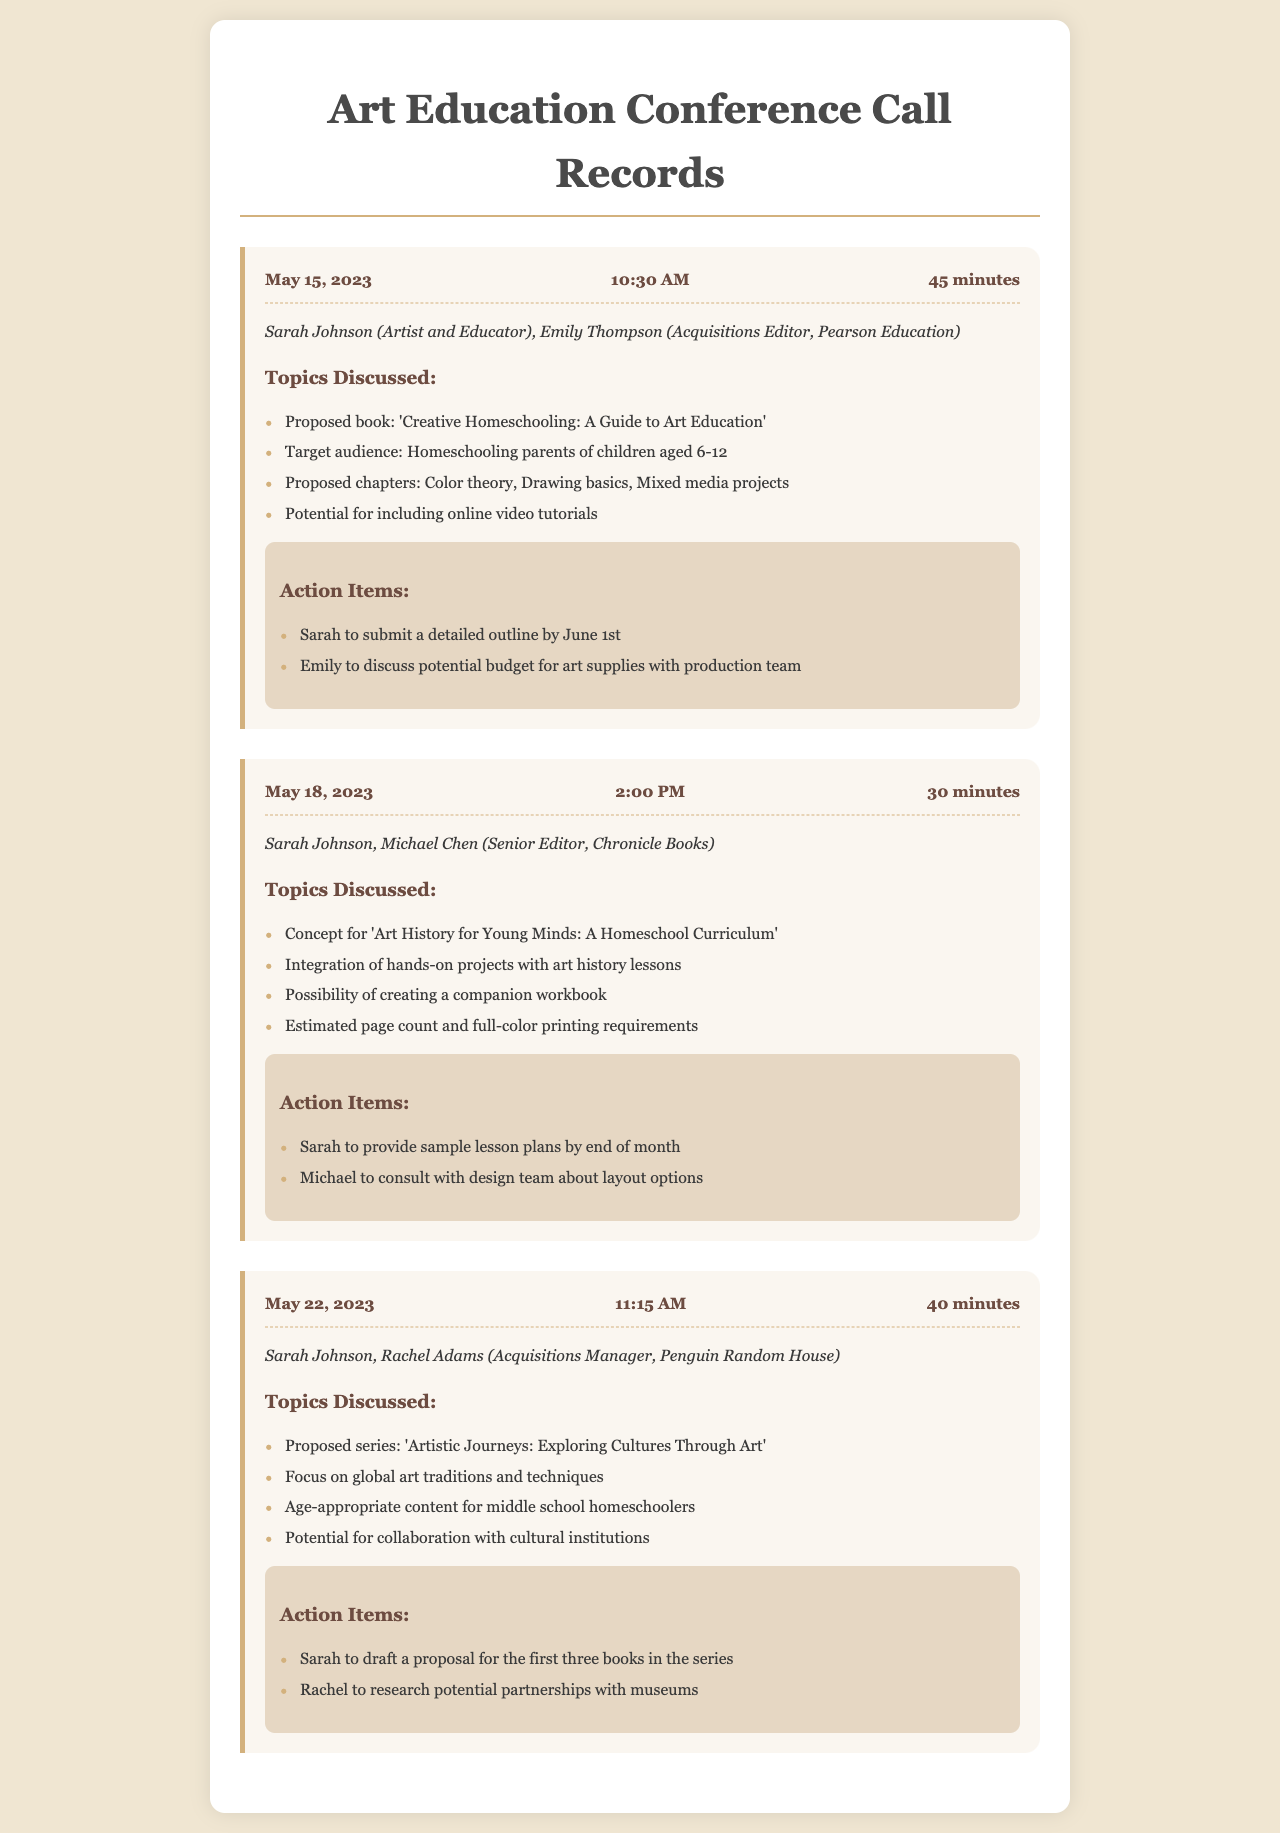What is the date of the first call? The date of the first call is found in the call record header.
Answer: May 15, 2023 Who was the acquisitions editor for Pearson Education? The name of the acquisitions editor for Pearson Education is mentioned in the call record under participants.
Answer: Emily Thompson What is the proposed title of the first book discussed? The proposed book title is listed in the topics discussed section of the first call record.
Answer: Creative Homeschooling: A Guide to Art Education How long was the second conference call? The duration of the second call is specified in the call record header.
Answer: 30 minutes Which participant is responsible for providing sample lesson plans? The action items section lists who is responsible for providing sample lesson plans in the second call record.
Answer: Sarah What series was discussed in the third call? The proposed series title can be found in the topics discussed section of the third call record.
Answer: Artistic Journeys: Exploring Cultures Through Art Which company is Rachel Adams associated with? Rachel Adams is mentioned as the acquisitions manager in the participants section of the third call record.
Answer: Penguin Random House How many proposed books will Sarah draft a proposal for? The action items in the third call indicate the number of books for which Sarah will draft a proposal.
Answer: Three books What topic includes hands-on projects? The topic of integrating hands-on projects is specified in the second call record.
Answer: Art History for Young Minds: A Homeschool Curriculum 